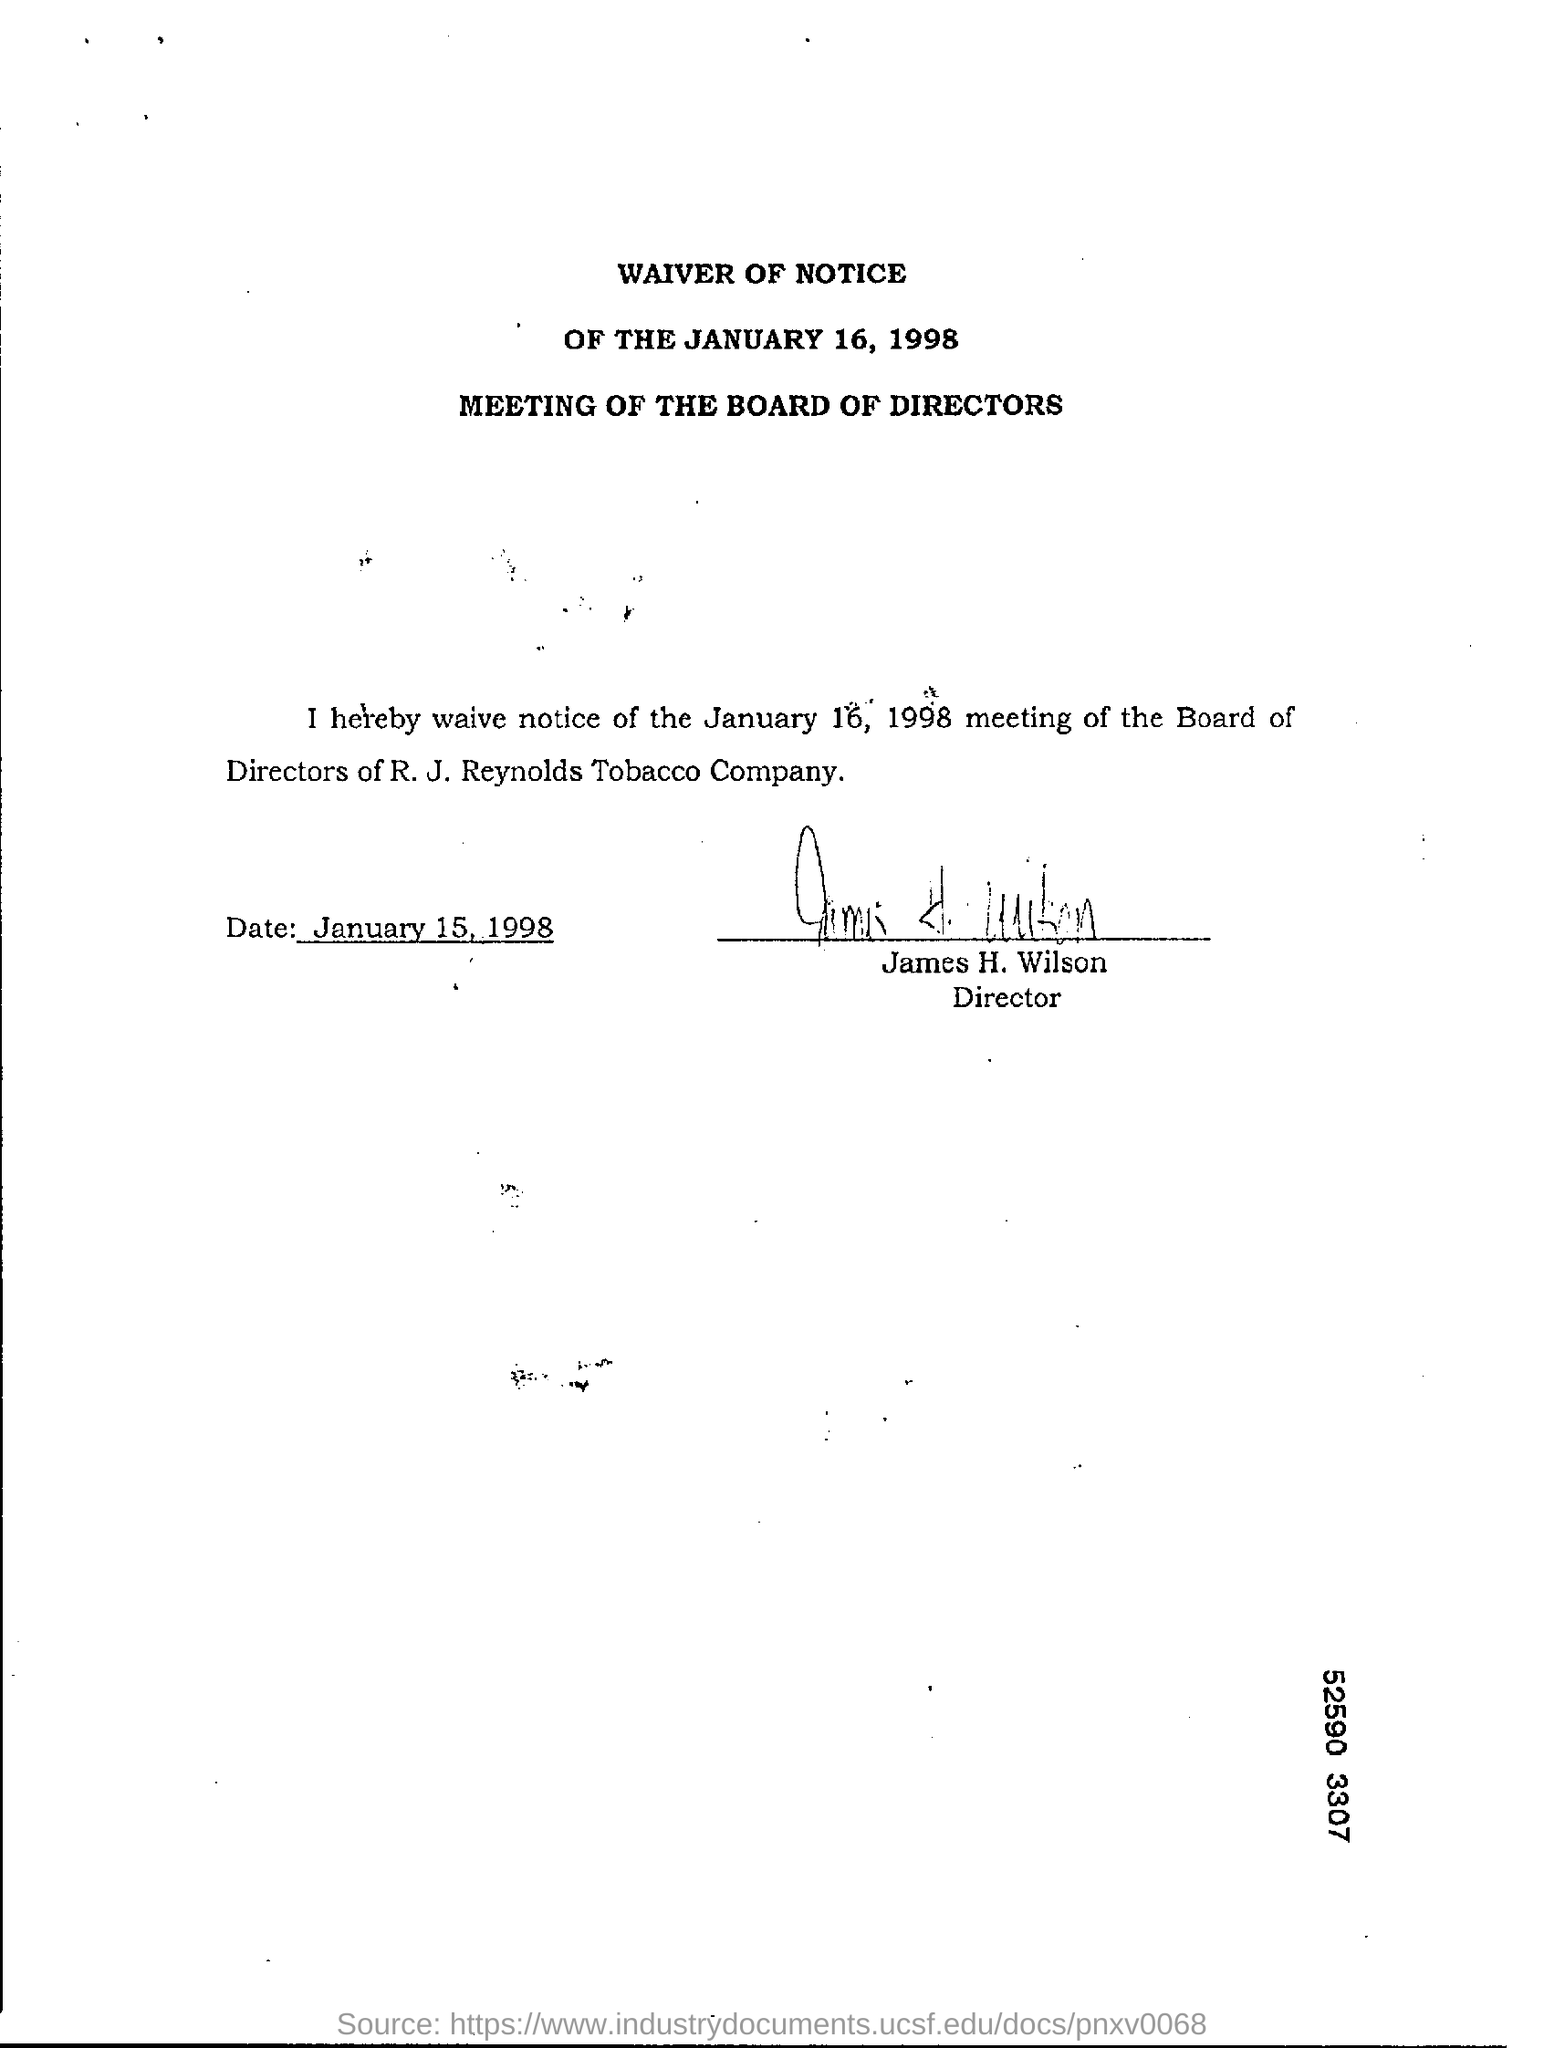What is the date of signing the document?
Make the answer very short. January 15, 1998. What is the name of the company?
Provide a succinct answer. R. J. Reynolds Tobacco company. What is the name of the Director?
Offer a very short reply. James H. Wilson. 